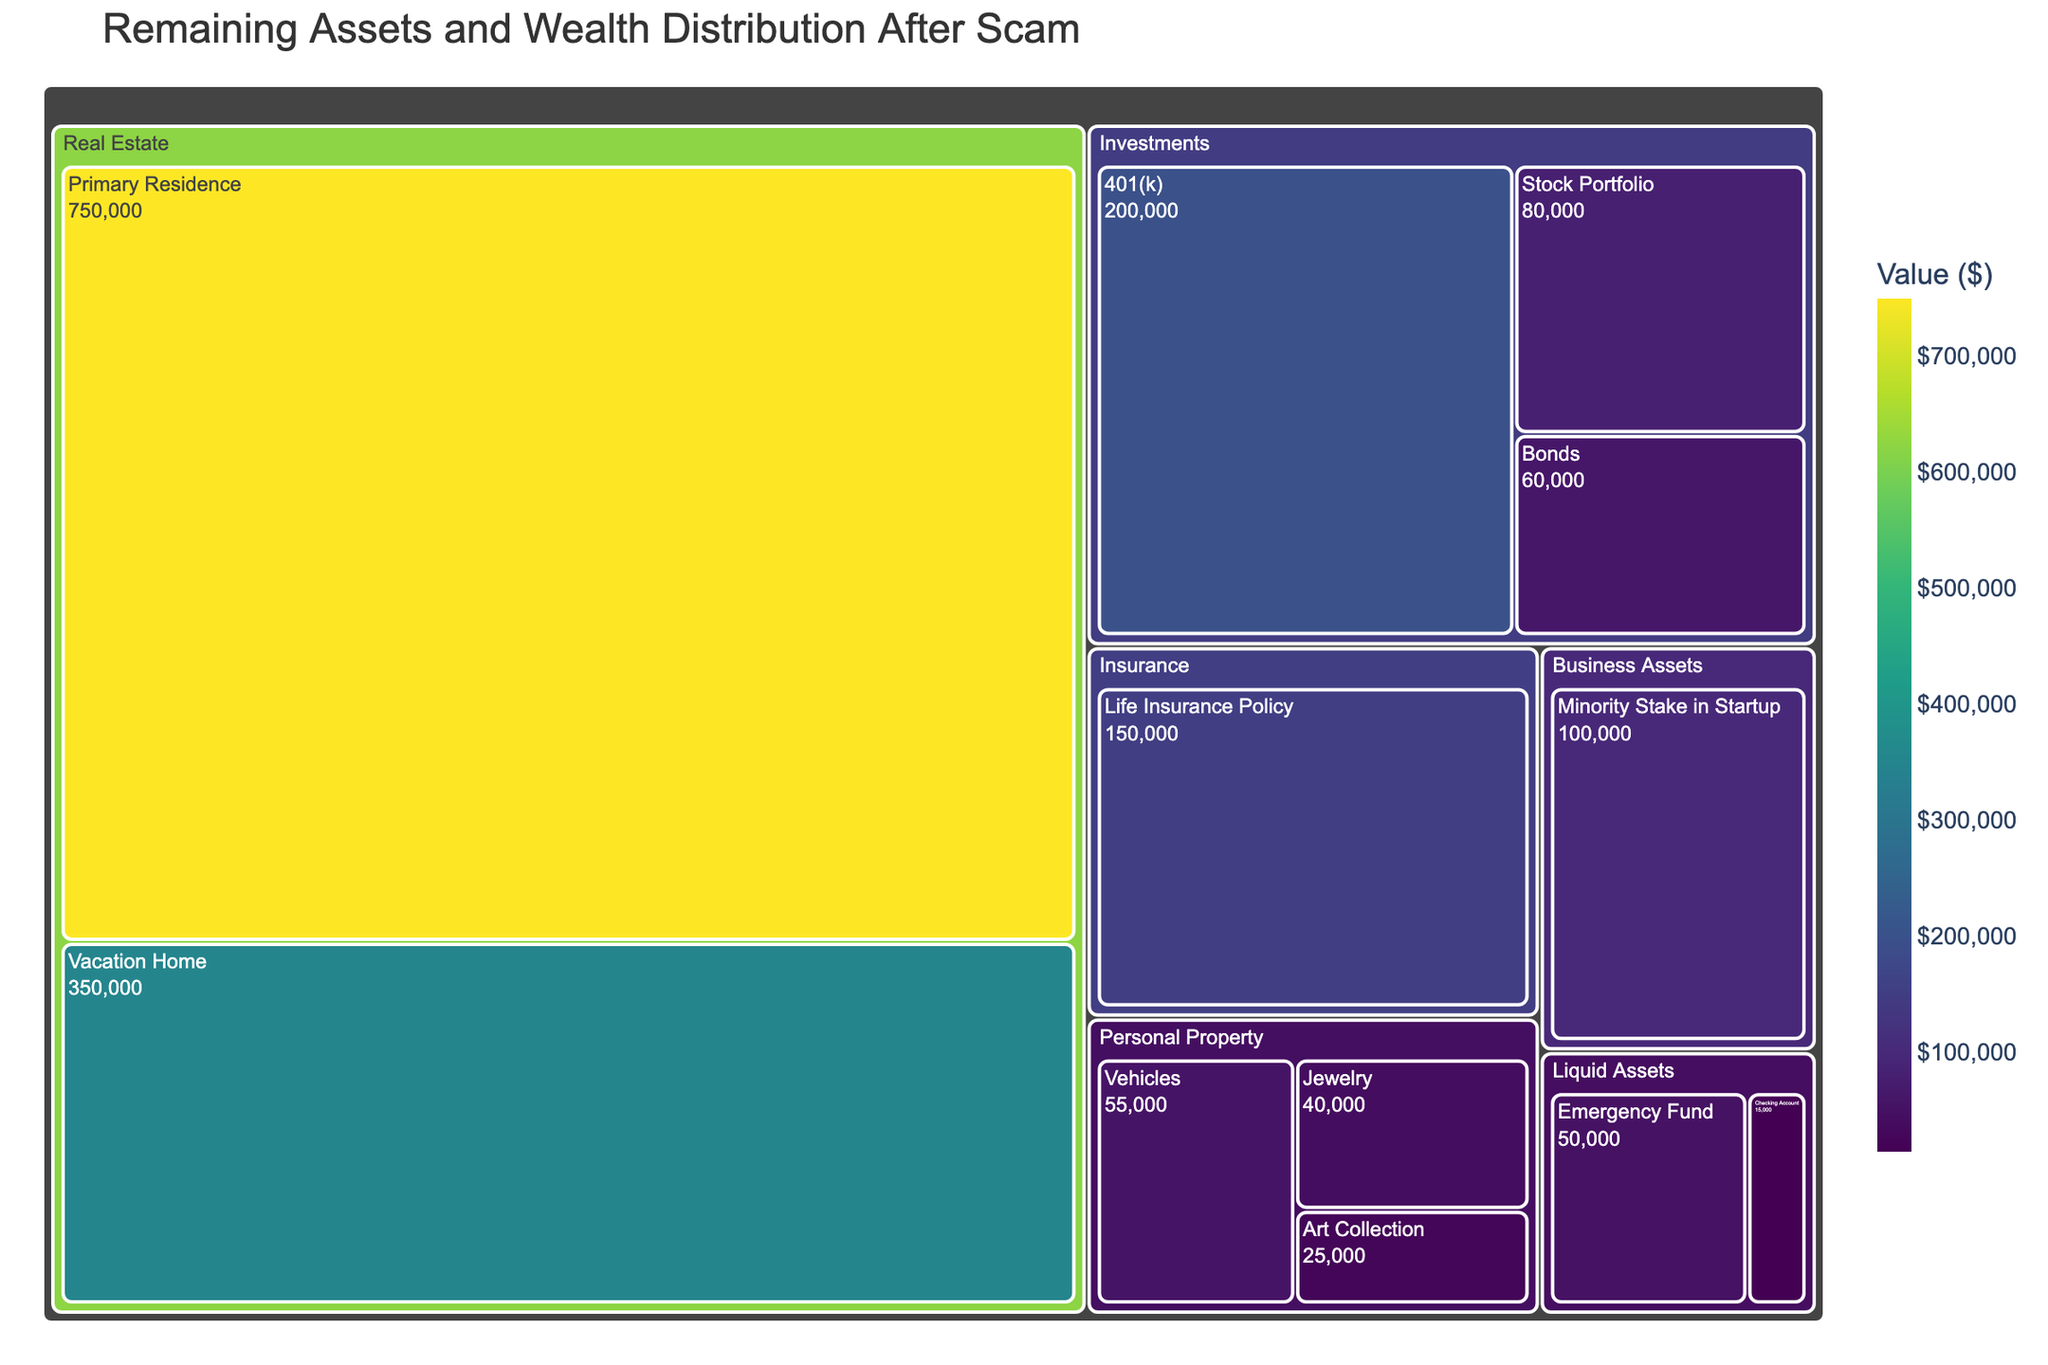What is the total value of the Investments category? To find the total value of the Investments category, sum up the values of its subcategories: 401(k) ($200,000), Stock Portfolio ($80,000), and Bonds ($60,000). The calculation is $200,000 + $80,000 + $60,000 = $340,000.
Answer: $340,000 Which subcategory has the highest value within the Real Estate category? Within the Real Estate category, compare the values of the Primary Residence ($750,000) and Vacation Home ($350,000). The Primary Residence has the higher value.
Answer: Primary Residence How much more is the value of the Primary Residence compared to the Vacation Home? The value of the Primary Residence is $750,000, and the value of the Vacation Home is $350,000. Subtract the value of the Vacation Home from the Primary Residence: $750,000 - $350,000 = $400,000.
Answer: $400,000 What is the total value of Liquid Assets? To find the total value of Liquid Assets, sum the values of the Emergency Fund ($50,000) and Checking Account ($15,000). The calculation is $50,000 + $15,000 = $65,000.
Answer: $65,000 Which has a greater value: Business Assets or Life Insurance Policy? Compare the values of Business Assets (Minority Stake in Startup: $100,000) and the Life Insurance Policy ($150,000). The Life Insurance Policy has a greater value.
Answer: Life Insurance Policy What is the combined value of the Emergency Fund and the Checking Account? Add the values of the Emergency Fund ($50,000) and the Checking Account ($15,000): $50,000 + $15,000 = $65,000.
Answer: $65,000 What category is under Life Insurance Policy, and what is its value? The Life Insurance Policy stands alone under the Insurance category, with a value of $150,000.
Answer: Insurance, $150,000 Which has more value: the Art Collection or Vehicles? Compare the values of the Art Collection ($25,000) and Vehicles ($55,000). The Vehicles has the higher value.
Answer: Vehicles What's the total value of Personal Property? Sum up the values of the subcategories under Personal Property: Jewelry ($40,000), Art Collection ($25,000), and Vehicles ($55,000). The calculation is $40,000 + $25,000 + $55,000 = $120,000.
Answer: $120,000 